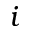<formula> <loc_0><loc_0><loc_500><loc_500>i</formula> 